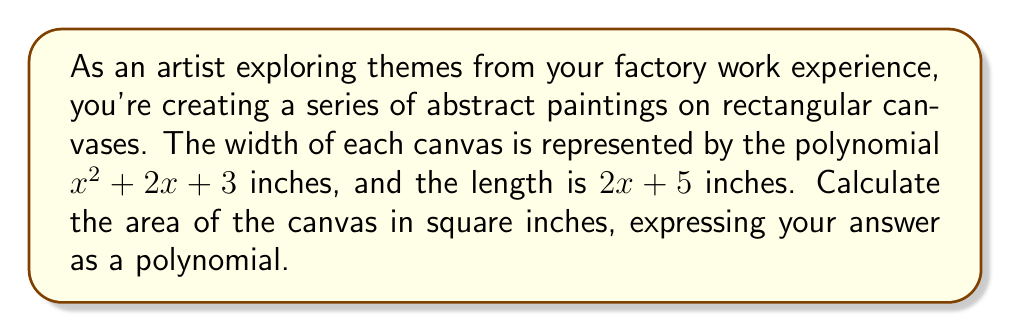Teach me how to tackle this problem. To calculate the area of a rectangular canvas, we need to multiply its width by its length.

1. Width of the canvas: $w = x^2 + 2x + 3$ inches
2. Length of the canvas: $l = 2x + 5$ inches

Area = width × length

$A = (x^2 + 2x + 3)(2x + 5)$

Let's multiply these polynomials using the FOIL method and combining like terms:

1. First terms: $x^2 \cdot 2x = 2x^3$
2. Outer terms: $x^2 \cdot 5 = 5x^2$
3. Inner terms: $2x \cdot 2x = 4x^2$
4. Last terms: $3 \cdot 2x = 6x$
5. First terms: $2x \cdot 5 = 10x$
6. Last terms: $3 \cdot 5 = 15$

Now, let's combine like terms:

$A = 2x^3 + 5x^2 + 4x^2 + 6x + 10x + 15$
$A = 2x^3 + 9x^2 + 16x + 15$

This polynomial represents the area of the canvas in square inches.
Answer: $A = 2x^3 + 9x^2 + 16x + 15$ square inches 